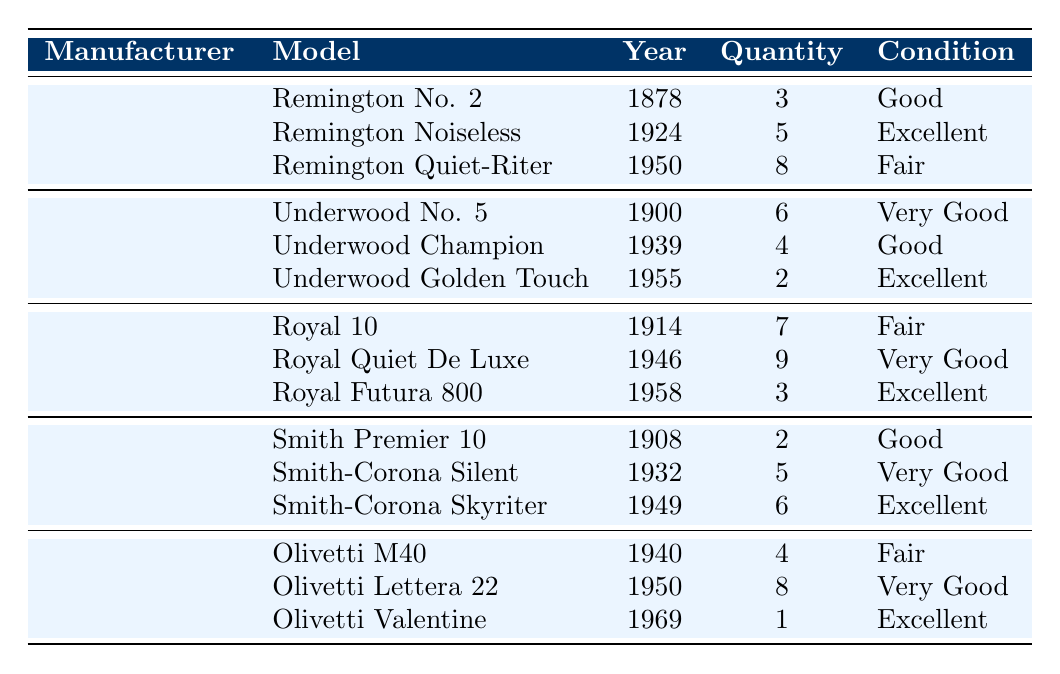What is the quantity of Remington Noiseless typewriters in the inventory? The table lists the models under the Remington manufacturer, including the Remington Noiseless. It shows that there are 5 units available under this model.
Answer: 5 Which manufacturer has the highest quantity of typewriters listed? By examining the total quantity per manufacturer: Remington has 16, Underwood has 12, Royal has 19, Smith Corona has 13, and Olivetti has 13. Royal has the highest total quantity with 19 units.
Answer: Royal How many Smith Corona models are in excellent condition? From the Smith Corona section in the table, only one model, the Smith-Corona Skyriter, is listed as being in excellent condition.
Answer: 1 What is the total quantity of Remington typewriters? The quantity of Remington typewriters includes: 3 (Remington No. 2) + 5 (Remington Noiseless) + 8 (Remington Quiet-Riter) = 16. The total quantity is 16.
Answer: 16 Is there a model manufactured by Olivetti that was produced after 1960? The Olivetti section shows only one model produced after 1960, which is the Olivetti Valentine from 1969. Therefore, the answer is yes.
Answer: Yes What is the average age of the typewriters listed for the Royal manufacturer? The Royal typewriters' ages are calculated as follows: Royal 10 (1914), Royal Quiet De Luxe (1946), Royal Futura 800 (1958). The ages are 2023-1914=109, 2023-1946=77, 2023-1958=65. The average is (109 + 77 + 65)/3 = 250/3 ≈ 83.33 years.
Answer: Approximately 83.33 years Which typewriter model is the newest in the entire inventory? The most recent typewriter model is the Olivetti Valentine, manufactured in 1969. All other models were produced before this year.
Answer: Olivetti Valentine How many typewriters are in fair condition across all manufacturers? From the table, under fair condition, there are: 1 (Remington Quiet-Riter) + 4 (Olivetti M40) + 7 (Royal 10) = 12 typewriters in fair condition.
Answer: 12 Which manufacturer has more than 2 models in excellent condition? Underwood and Olivetti both have models in excellent condition: Olivetti has 1 and Underwood has 1. Hence, none of the manufacturers have more than 2 models in excellent condition.
Answer: No What is the total number of typewriters in good condition? The total quantity in good condition includes: 3 (Remington No. 2) + 6 (Underwood No. 5) + 2 (Smith Premier 10) + 4 (Olivetti M40) = 15. Therefore, there are 15 typewriters in good condition.
Answer: 15 